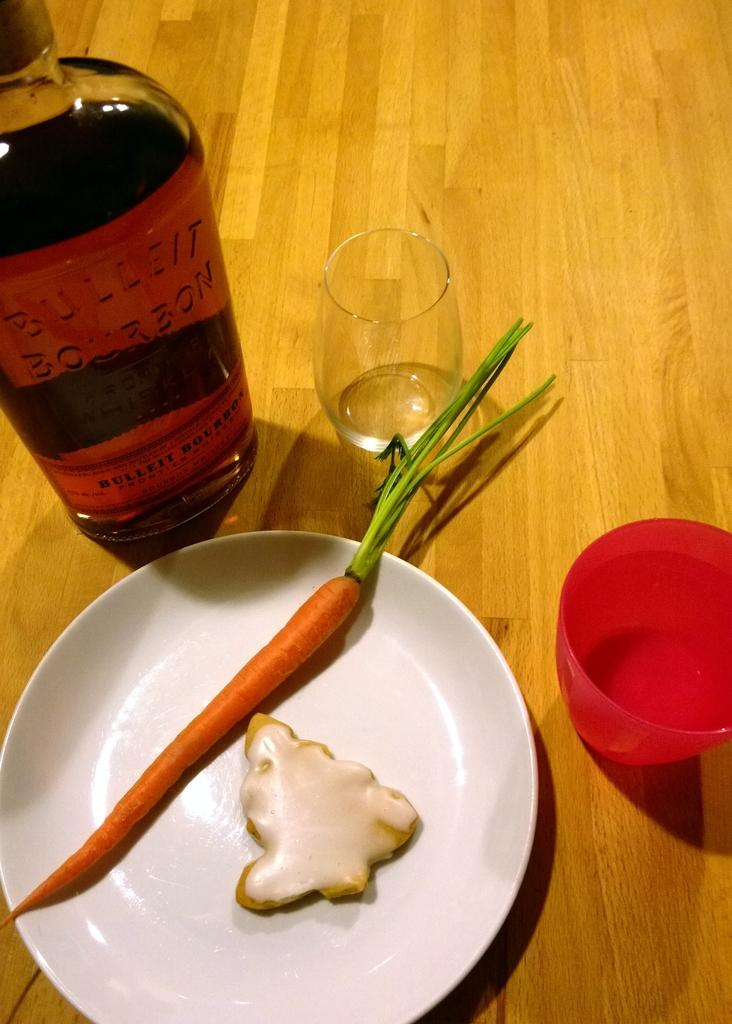<image>
Summarize the visual content of the image. A bottle of Bulleit bourbon next to a plate with a carrot and a cookie. 